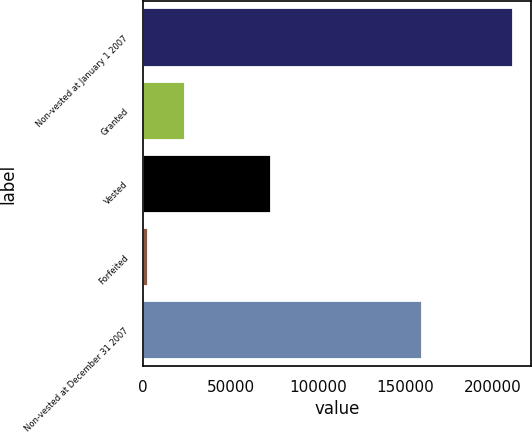Convert chart. <chart><loc_0><loc_0><loc_500><loc_500><bar_chart><fcel>Non-vested at January 1 2007<fcel>Granted<fcel>Vested<fcel>Forfeited<fcel>Non-vested at December 31 2007<nl><fcel>211605<fcel>23669<fcel>73250<fcel>2636<fcel>159388<nl></chart> 